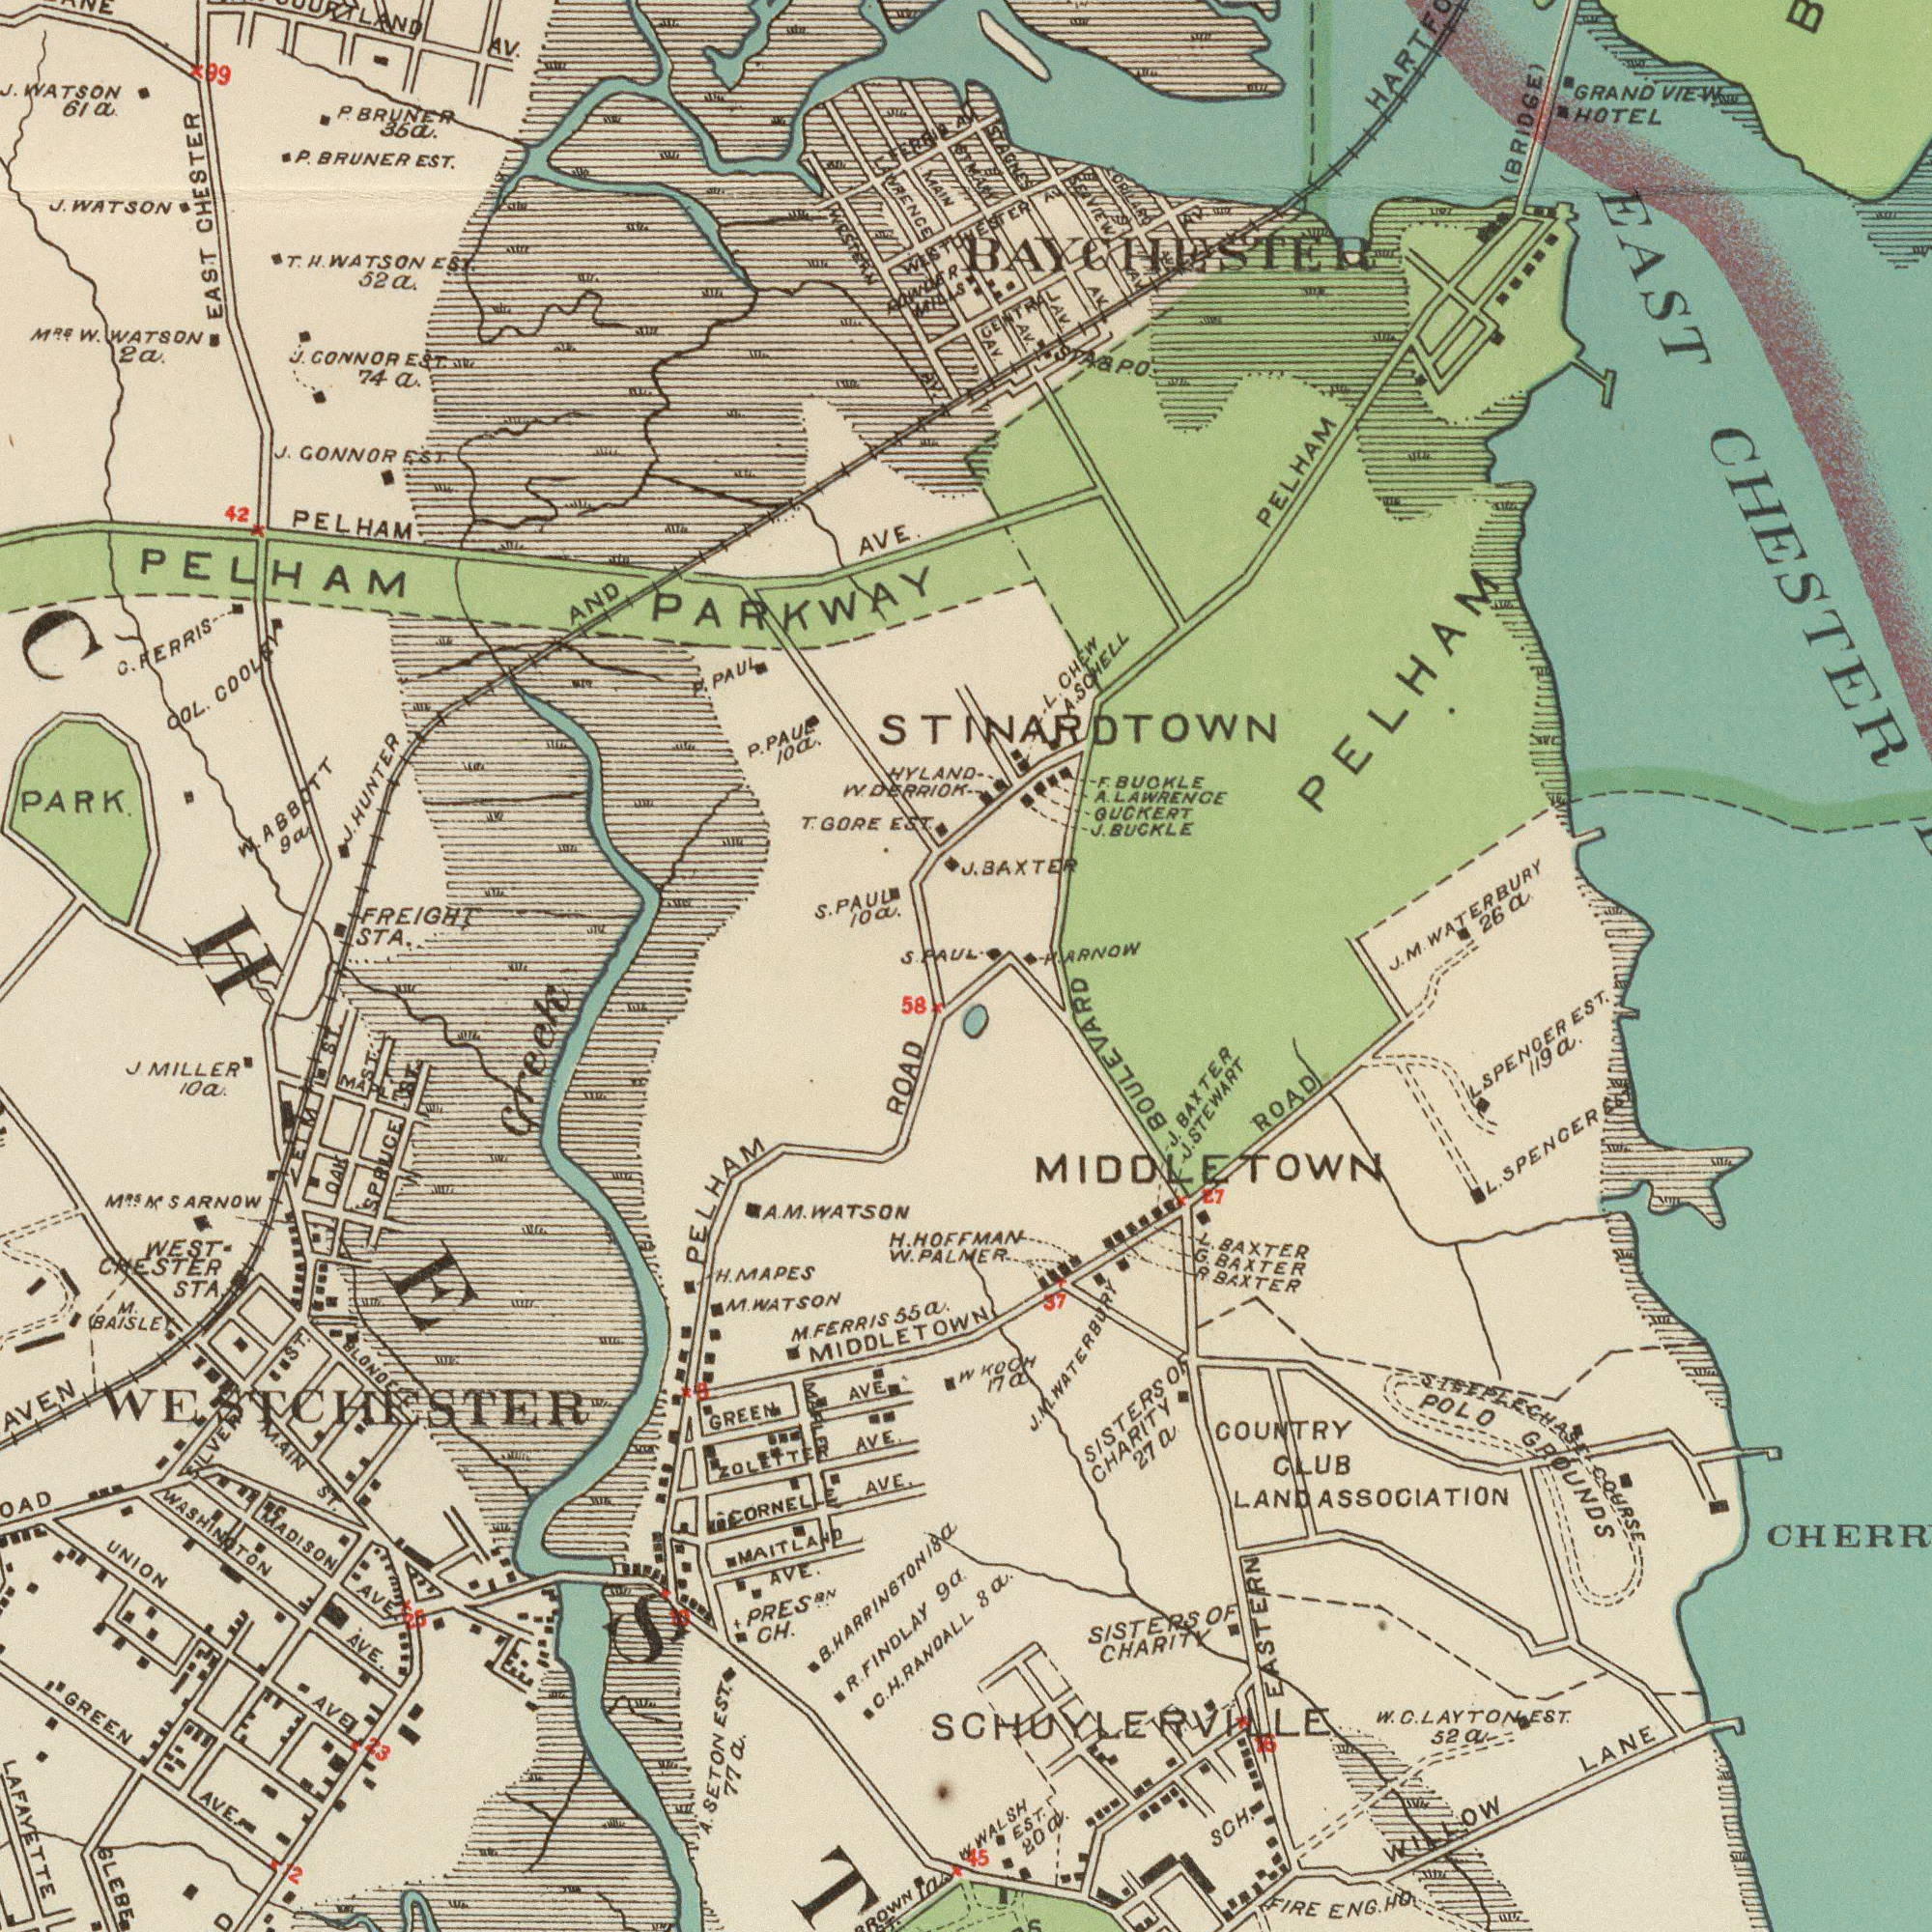What text is visible in the upper-left corner? PELHAM AVE. LAWRENCE J. GONNOR EST. EAST CHESTER J. GONNOR EST. 74a. J. J.HUNTER FREIGHT STA. AV. P. P.PAUE 10a. AND HYLAN T. H. WATSON EST. 52a. W. ABBOTT 9a P. BRUNER 36a. MRS W. WATSON 2a. COL. COOLEY P. BRUNER EST. T. GORE EST. PARK J. WATSON 42 PELHAM PARKWAY S. PAUL 10a. MAIN J. WATSON 61a. FERRIS P. PAUL WESTERN AVI. S. PAUL. W. DERRIOK 99 C. RERRIS RAWAER MILLS What text can you see in the bottom-right section? ROAD 8a. HOFFMAN PLAMER STEEPLECHASE COURSE SISTERS OF CHARITY 27a COUNTRY CLUB LAND ASSOCIATION L. BAXTER POLO GROUNDS L. SPENGER EST. WALH EST. 80a. WILLOW LANE R. BAXTER EASTERN BOULEVARD J. STEWART SPENGER EST. 119a. SCH. J. BAXTER G. BAXTER SISTERS OF CHARITY W KOCH 17a SCHUYLERVILLE FIRE ENG. HO 15 J. M. WATERBURY 27 W. ..CLAYTONT 52a 57 MIDDLETOWN What text can you see in the bottom-left section? GLEBE H. MAPES A. M. WATSON Creek GREEN AVE. R. FINDLAY 9a LAFAYETTE ZOLETTER AVE. MADISON AVE. J. MILLER 10a M. FERRIS 55a. M. BAISLE MAIN ST. WEST CHESTER STA. GREEM AVE. WASHINGTON AVE. MIDDLETOW M.RSN SARNOW PRES.BN CH. MAITLAND AVE. A. SETON EST. 77a. 58 PELHAM ROAD SPRUCE ST. M. WATSON La. ST CORNELLE AVE. OAK ST. C. H. RANDALL UNION AVE. BLONDELL H. W. WESTCHESTER ELM ST. B. HARRINGTON 18a SILVER ST. MAPLE MAPLE 12 23 25 8 10 What text is visible in the upper-right corner? AV. AV. AV. J. BAXTER J. BUCKLE STAGNES AV. GUCKERT STINARDTOWN EAST CHESTER WESTCHESTER AV. GRAND VIEW HOTEL L. CHEW PELHAM F. BUOKLE A. SCHELL STA&PO ORILARD BAYCHESTER SEAVIEW AV. J. M. WATERBURY 26a (BRIDGE) PELHAM A. LAWRENGE P. ARNOW CENTRAL AV. STMAN AV. 